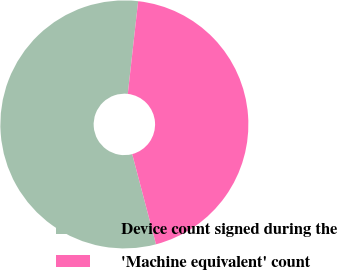Convert chart. <chart><loc_0><loc_0><loc_500><loc_500><pie_chart><fcel>Device count signed during the<fcel>'Machine equivalent' count<nl><fcel>55.88%<fcel>44.12%<nl></chart> 